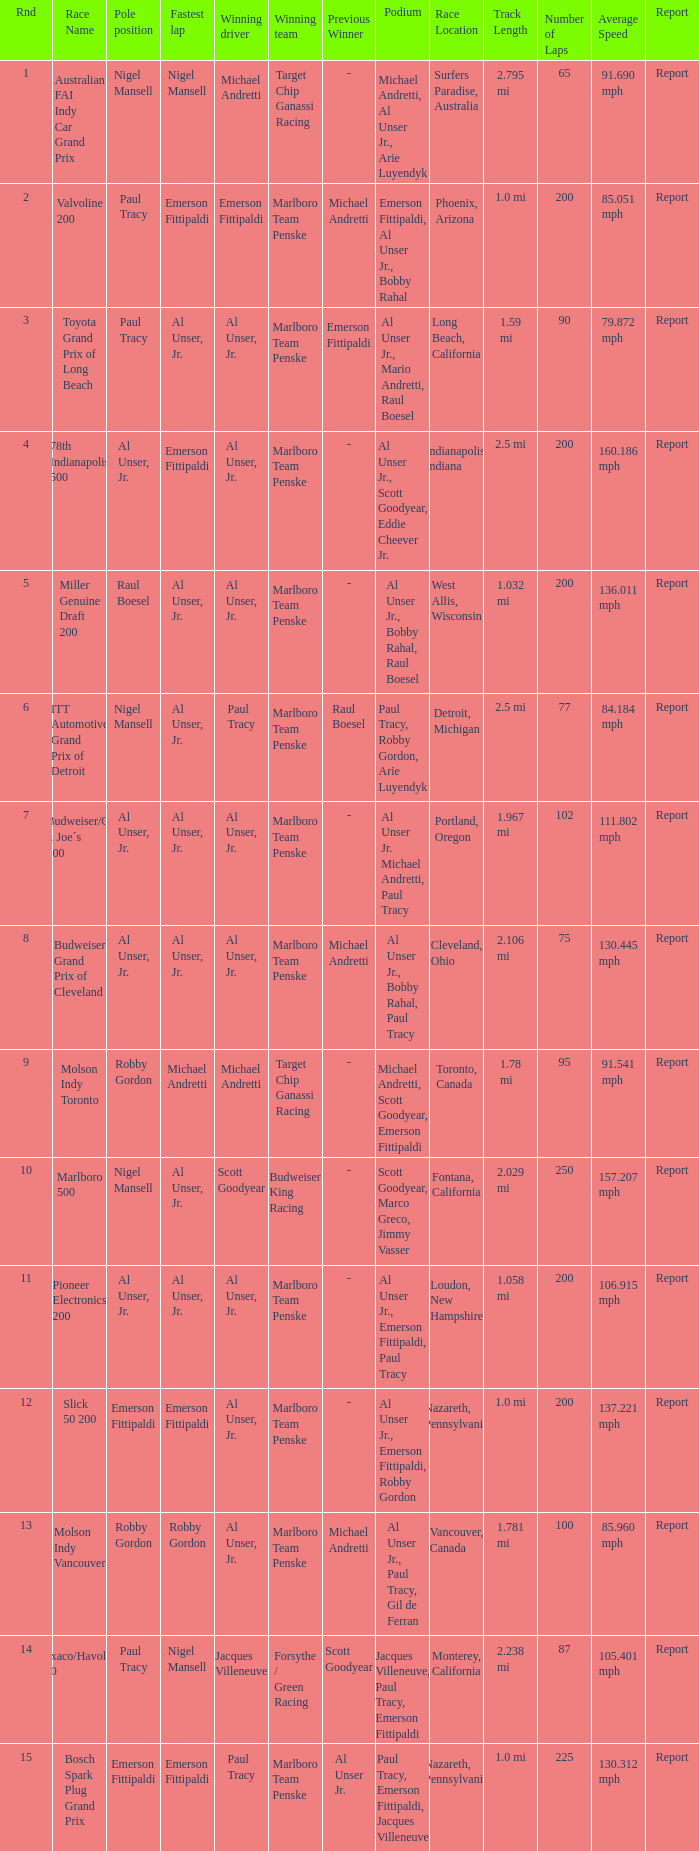Who was on the pole position in the Texaco/Havoline 200 race? Paul Tracy. 